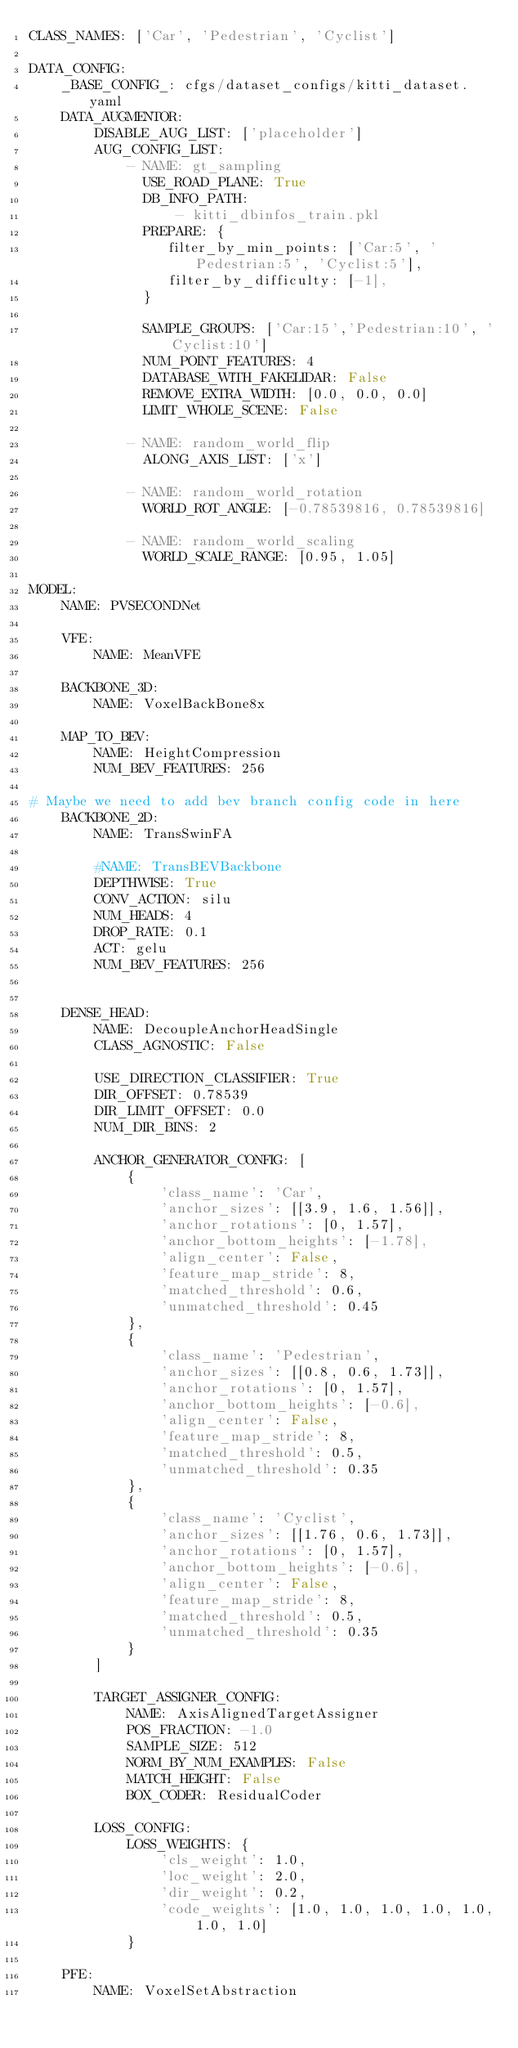Convert code to text. <code><loc_0><loc_0><loc_500><loc_500><_YAML_>CLASS_NAMES: ['Car', 'Pedestrian', 'Cyclist']

DATA_CONFIG:
    _BASE_CONFIG_: cfgs/dataset_configs/kitti_dataset.yaml
    DATA_AUGMENTOR:
        DISABLE_AUG_LIST: ['placeholder']
        AUG_CONFIG_LIST:
            - NAME: gt_sampling
              USE_ROAD_PLANE: True
              DB_INFO_PATH:
                  - kitti_dbinfos_train.pkl
              PREPARE: {
                 filter_by_min_points: ['Car:5', 'Pedestrian:5', 'Cyclist:5'],
                 filter_by_difficulty: [-1],
              }

              SAMPLE_GROUPS: ['Car:15','Pedestrian:10', 'Cyclist:10']
              NUM_POINT_FEATURES: 4
              DATABASE_WITH_FAKELIDAR: False
              REMOVE_EXTRA_WIDTH: [0.0, 0.0, 0.0]
              LIMIT_WHOLE_SCENE: False

            - NAME: random_world_flip
              ALONG_AXIS_LIST: ['x']

            - NAME: random_world_rotation
              WORLD_ROT_ANGLE: [-0.78539816, 0.78539816]

            - NAME: random_world_scaling
              WORLD_SCALE_RANGE: [0.95, 1.05]

MODEL:
    NAME: PVSECONDNet

    VFE:
        NAME: MeanVFE

    BACKBONE_3D:
        NAME: VoxelBackBone8x

    MAP_TO_BEV:
        NAME: HeightCompression
        NUM_BEV_FEATURES: 256

# Maybe we need to add bev branch config code in here
    BACKBONE_2D:
        NAME: TransSwinFA

        #NAME: TransBEVBackbone
        DEPTHWISE: True
        CONV_ACTION: silu
        NUM_HEADS: 4
        DROP_RATE: 0.1
        ACT: gelu
        NUM_BEV_FEATURES: 256


    DENSE_HEAD:
        NAME: DecoupleAnchorHeadSingle
        CLASS_AGNOSTIC: False

        USE_DIRECTION_CLASSIFIER: True
        DIR_OFFSET: 0.78539
        DIR_LIMIT_OFFSET: 0.0
        NUM_DIR_BINS: 2

        ANCHOR_GENERATOR_CONFIG: [
            {
                'class_name': 'Car',
                'anchor_sizes': [[3.9, 1.6, 1.56]],
                'anchor_rotations': [0, 1.57],
                'anchor_bottom_heights': [-1.78],
                'align_center': False,
                'feature_map_stride': 8,
                'matched_threshold': 0.6,
                'unmatched_threshold': 0.45
            },
            {
                'class_name': 'Pedestrian',
                'anchor_sizes': [[0.8, 0.6, 1.73]],
                'anchor_rotations': [0, 1.57],
                'anchor_bottom_heights': [-0.6],
                'align_center': False,
                'feature_map_stride': 8,
                'matched_threshold': 0.5,
                'unmatched_threshold': 0.35
            },
            {
                'class_name': 'Cyclist',
                'anchor_sizes': [[1.76, 0.6, 1.73]],
                'anchor_rotations': [0, 1.57],
                'anchor_bottom_heights': [-0.6],
                'align_center': False,
                'feature_map_stride': 8,
                'matched_threshold': 0.5,
                'unmatched_threshold': 0.35
            }
        ]

        TARGET_ASSIGNER_CONFIG:
            NAME: AxisAlignedTargetAssigner
            POS_FRACTION: -1.0
            SAMPLE_SIZE: 512
            NORM_BY_NUM_EXAMPLES: False
            MATCH_HEIGHT: False
            BOX_CODER: ResidualCoder

        LOSS_CONFIG:
            LOSS_WEIGHTS: {
                'cls_weight': 1.0,
                'loc_weight': 2.0,
                'dir_weight': 0.2,
                'code_weights': [1.0, 1.0, 1.0, 1.0, 1.0, 1.0, 1.0]
            }

    PFE:
        NAME: VoxelSetAbstraction</code> 